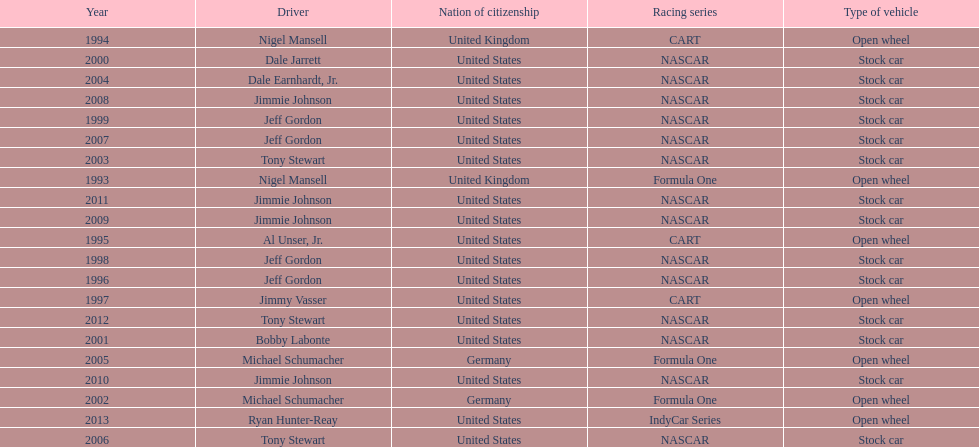How many times did jeff gordon win the award? 4. 